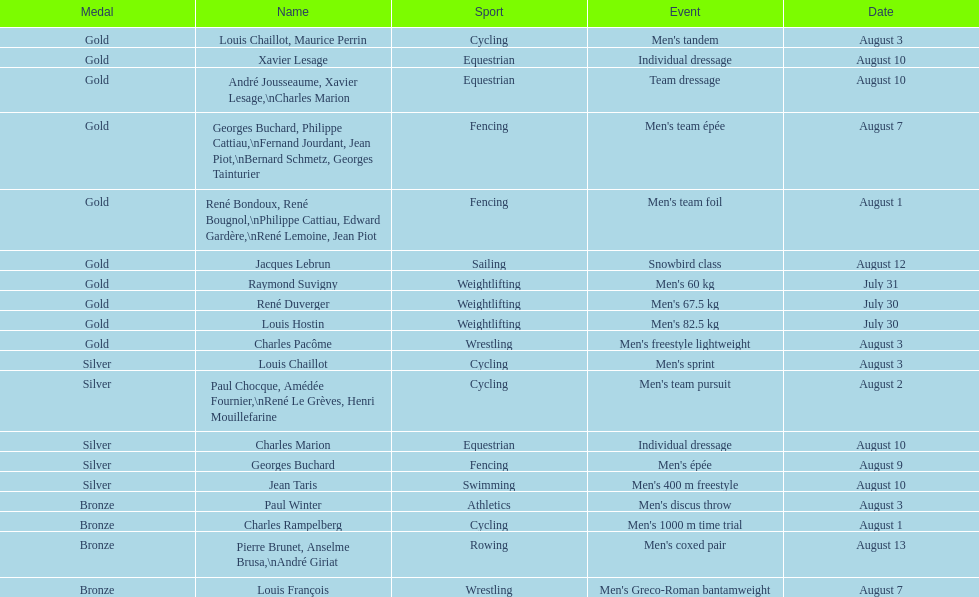Did the number of gold medals won surpass the silver medals? Yes. 